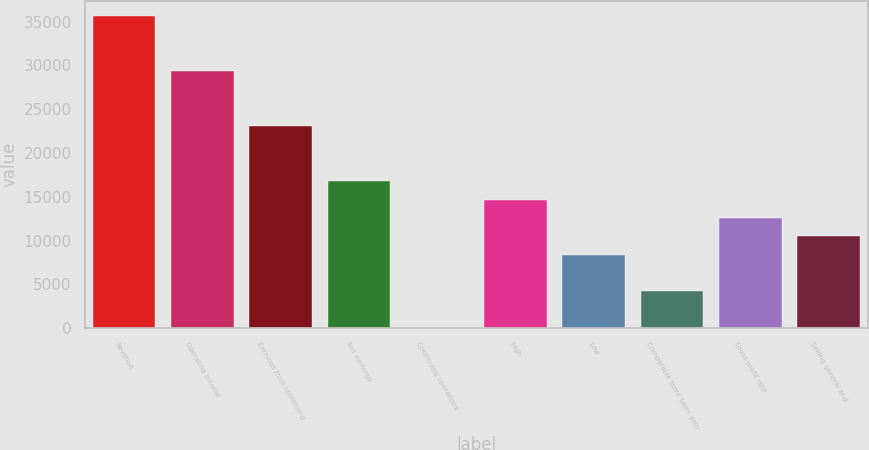Convert chart. <chart><loc_0><loc_0><loc_500><loc_500><bar_chart><fcel>Revenue<fcel>Operating income<fcel>Earnings from continuing<fcel>Net earnings<fcel>Continuing operations<fcel>High<fcel>Low<fcel>Comparable store sales gain<fcel>Gross profit rate<fcel>Selling general and<nl><fcel>35602.2<fcel>29319.7<fcel>23037.1<fcel>16754.6<fcel>1.27<fcel>14660.5<fcel>8377.95<fcel>4189.61<fcel>12566.3<fcel>10472.1<nl></chart> 